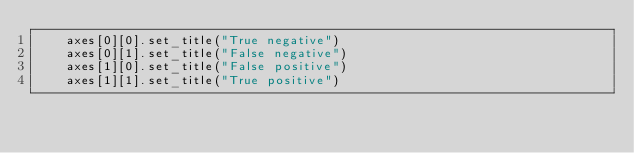<code> <loc_0><loc_0><loc_500><loc_500><_Python_>    axes[0][0].set_title("True negative")
    axes[0][1].set_title("False negative")
    axes[1][0].set_title("False positive")
    axes[1][1].set_title("True positive")
</code> 